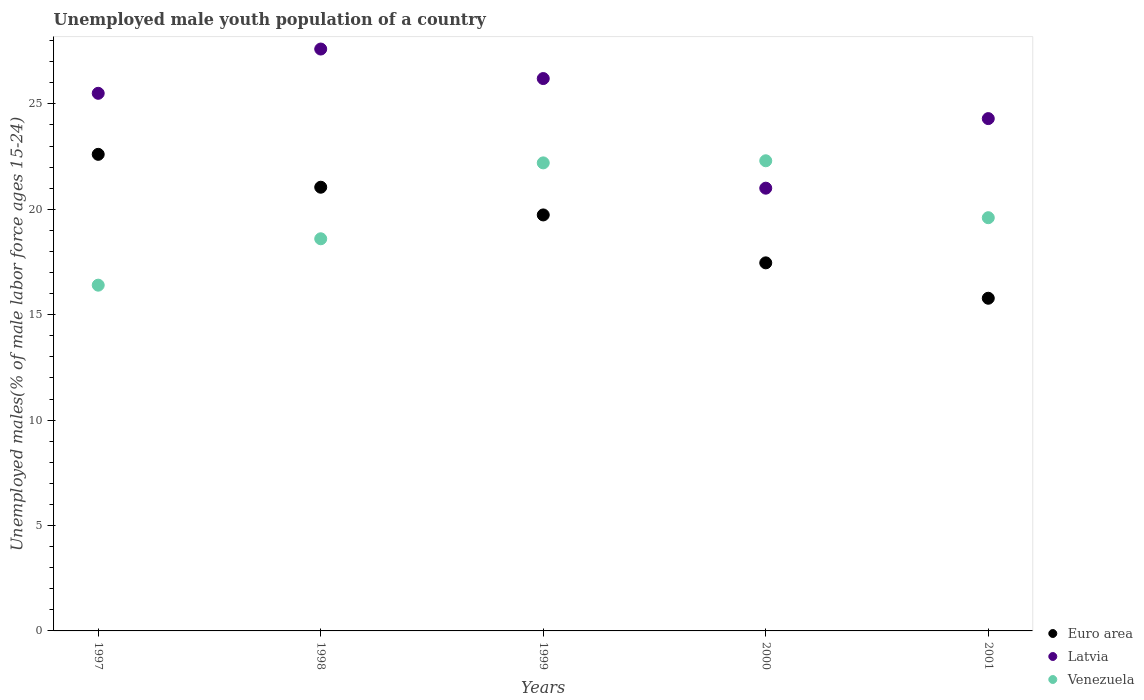What is the percentage of unemployed male youth population in Euro area in 2001?
Offer a terse response. 15.78. Across all years, what is the maximum percentage of unemployed male youth population in Venezuela?
Ensure brevity in your answer.  22.3. Across all years, what is the minimum percentage of unemployed male youth population in Venezuela?
Keep it short and to the point. 16.4. In which year was the percentage of unemployed male youth population in Latvia maximum?
Provide a short and direct response. 1998. In which year was the percentage of unemployed male youth population in Venezuela minimum?
Provide a short and direct response. 1997. What is the total percentage of unemployed male youth population in Euro area in the graph?
Provide a short and direct response. 96.62. What is the difference between the percentage of unemployed male youth population in Venezuela in 1999 and that in 2001?
Give a very brief answer. 2.6. What is the difference between the percentage of unemployed male youth population in Euro area in 1998 and the percentage of unemployed male youth population in Venezuela in 2001?
Offer a terse response. 1.45. What is the average percentage of unemployed male youth population in Venezuela per year?
Keep it short and to the point. 19.82. In the year 1998, what is the difference between the percentage of unemployed male youth population in Venezuela and percentage of unemployed male youth population in Euro area?
Keep it short and to the point. -2.45. In how many years, is the percentage of unemployed male youth population in Venezuela greater than 5 %?
Ensure brevity in your answer.  5. What is the ratio of the percentage of unemployed male youth population in Euro area in 1998 to that in 2000?
Your answer should be compact. 1.21. Is the percentage of unemployed male youth population in Latvia in 2000 less than that in 2001?
Offer a very short reply. Yes. Is the difference between the percentage of unemployed male youth population in Venezuela in 1998 and 2001 greater than the difference between the percentage of unemployed male youth population in Euro area in 1998 and 2001?
Keep it short and to the point. No. What is the difference between the highest and the second highest percentage of unemployed male youth population in Euro area?
Provide a succinct answer. 1.56. What is the difference between the highest and the lowest percentage of unemployed male youth population in Euro area?
Make the answer very short. 6.83. In how many years, is the percentage of unemployed male youth population in Euro area greater than the average percentage of unemployed male youth population in Euro area taken over all years?
Offer a terse response. 3. Is the percentage of unemployed male youth population in Venezuela strictly greater than the percentage of unemployed male youth population in Euro area over the years?
Provide a succinct answer. No. How many years are there in the graph?
Keep it short and to the point. 5. What is the difference between two consecutive major ticks on the Y-axis?
Your answer should be very brief. 5. Does the graph contain any zero values?
Your answer should be compact. No. What is the title of the graph?
Your answer should be compact. Unemployed male youth population of a country. Does "Middle income" appear as one of the legend labels in the graph?
Offer a terse response. No. What is the label or title of the X-axis?
Offer a terse response. Years. What is the label or title of the Y-axis?
Ensure brevity in your answer.  Unemployed males(% of male labor force ages 15-24). What is the Unemployed males(% of male labor force ages 15-24) in Euro area in 1997?
Give a very brief answer. 22.61. What is the Unemployed males(% of male labor force ages 15-24) in Venezuela in 1997?
Offer a very short reply. 16.4. What is the Unemployed males(% of male labor force ages 15-24) of Euro area in 1998?
Provide a short and direct response. 21.05. What is the Unemployed males(% of male labor force ages 15-24) in Latvia in 1998?
Keep it short and to the point. 27.6. What is the Unemployed males(% of male labor force ages 15-24) of Venezuela in 1998?
Keep it short and to the point. 18.6. What is the Unemployed males(% of male labor force ages 15-24) in Euro area in 1999?
Make the answer very short. 19.73. What is the Unemployed males(% of male labor force ages 15-24) of Latvia in 1999?
Make the answer very short. 26.2. What is the Unemployed males(% of male labor force ages 15-24) in Venezuela in 1999?
Offer a terse response. 22.2. What is the Unemployed males(% of male labor force ages 15-24) of Euro area in 2000?
Your response must be concise. 17.46. What is the Unemployed males(% of male labor force ages 15-24) of Latvia in 2000?
Offer a terse response. 21. What is the Unemployed males(% of male labor force ages 15-24) in Venezuela in 2000?
Offer a very short reply. 22.3. What is the Unemployed males(% of male labor force ages 15-24) of Euro area in 2001?
Your answer should be compact. 15.78. What is the Unemployed males(% of male labor force ages 15-24) of Latvia in 2001?
Ensure brevity in your answer.  24.3. What is the Unemployed males(% of male labor force ages 15-24) in Venezuela in 2001?
Make the answer very short. 19.6. Across all years, what is the maximum Unemployed males(% of male labor force ages 15-24) of Euro area?
Offer a terse response. 22.61. Across all years, what is the maximum Unemployed males(% of male labor force ages 15-24) of Latvia?
Provide a succinct answer. 27.6. Across all years, what is the maximum Unemployed males(% of male labor force ages 15-24) of Venezuela?
Give a very brief answer. 22.3. Across all years, what is the minimum Unemployed males(% of male labor force ages 15-24) of Euro area?
Provide a short and direct response. 15.78. Across all years, what is the minimum Unemployed males(% of male labor force ages 15-24) in Latvia?
Your response must be concise. 21. Across all years, what is the minimum Unemployed males(% of male labor force ages 15-24) of Venezuela?
Provide a short and direct response. 16.4. What is the total Unemployed males(% of male labor force ages 15-24) of Euro area in the graph?
Your answer should be compact. 96.62. What is the total Unemployed males(% of male labor force ages 15-24) in Latvia in the graph?
Provide a short and direct response. 124.6. What is the total Unemployed males(% of male labor force ages 15-24) in Venezuela in the graph?
Ensure brevity in your answer.  99.1. What is the difference between the Unemployed males(% of male labor force ages 15-24) of Euro area in 1997 and that in 1998?
Provide a succinct answer. 1.56. What is the difference between the Unemployed males(% of male labor force ages 15-24) of Euro area in 1997 and that in 1999?
Give a very brief answer. 2.87. What is the difference between the Unemployed males(% of male labor force ages 15-24) in Venezuela in 1997 and that in 1999?
Ensure brevity in your answer.  -5.8. What is the difference between the Unemployed males(% of male labor force ages 15-24) of Euro area in 1997 and that in 2000?
Provide a succinct answer. 5.15. What is the difference between the Unemployed males(% of male labor force ages 15-24) of Euro area in 1997 and that in 2001?
Give a very brief answer. 6.83. What is the difference between the Unemployed males(% of male labor force ages 15-24) in Euro area in 1998 and that in 1999?
Keep it short and to the point. 1.31. What is the difference between the Unemployed males(% of male labor force ages 15-24) of Euro area in 1998 and that in 2000?
Provide a succinct answer. 3.59. What is the difference between the Unemployed males(% of male labor force ages 15-24) in Latvia in 1998 and that in 2000?
Your answer should be compact. 6.6. What is the difference between the Unemployed males(% of male labor force ages 15-24) of Venezuela in 1998 and that in 2000?
Offer a very short reply. -3.7. What is the difference between the Unemployed males(% of male labor force ages 15-24) in Euro area in 1998 and that in 2001?
Ensure brevity in your answer.  5.27. What is the difference between the Unemployed males(% of male labor force ages 15-24) of Venezuela in 1998 and that in 2001?
Offer a terse response. -1. What is the difference between the Unemployed males(% of male labor force ages 15-24) of Euro area in 1999 and that in 2000?
Give a very brief answer. 2.27. What is the difference between the Unemployed males(% of male labor force ages 15-24) in Latvia in 1999 and that in 2000?
Your response must be concise. 5.2. What is the difference between the Unemployed males(% of male labor force ages 15-24) of Euro area in 1999 and that in 2001?
Provide a short and direct response. 3.95. What is the difference between the Unemployed males(% of male labor force ages 15-24) of Euro area in 2000 and that in 2001?
Offer a terse response. 1.68. What is the difference between the Unemployed males(% of male labor force ages 15-24) in Latvia in 2000 and that in 2001?
Offer a very short reply. -3.3. What is the difference between the Unemployed males(% of male labor force ages 15-24) of Venezuela in 2000 and that in 2001?
Provide a short and direct response. 2.7. What is the difference between the Unemployed males(% of male labor force ages 15-24) in Euro area in 1997 and the Unemployed males(% of male labor force ages 15-24) in Latvia in 1998?
Keep it short and to the point. -4.99. What is the difference between the Unemployed males(% of male labor force ages 15-24) in Euro area in 1997 and the Unemployed males(% of male labor force ages 15-24) in Venezuela in 1998?
Offer a very short reply. 4.01. What is the difference between the Unemployed males(% of male labor force ages 15-24) of Latvia in 1997 and the Unemployed males(% of male labor force ages 15-24) of Venezuela in 1998?
Your answer should be compact. 6.9. What is the difference between the Unemployed males(% of male labor force ages 15-24) of Euro area in 1997 and the Unemployed males(% of male labor force ages 15-24) of Latvia in 1999?
Keep it short and to the point. -3.59. What is the difference between the Unemployed males(% of male labor force ages 15-24) of Euro area in 1997 and the Unemployed males(% of male labor force ages 15-24) of Venezuela in 1999?
Keep it short and to the point. 0.41. What is the difference between the Unemployed males(% of male labor force ages 15-24) of Latvia in 1997 and the Unemployed males(% of male labor force ages 15-24) of Venezuela in 1999?
Provide a succinct answer. 3.3. What is the difference between the Unemployed males(% of male labor force ages 15-24) in Euro area in 1997 and the Unemployed males(% of male labor force ages 15-24) in Latvia in 2000?
Provide a succinct answer. 1.61. What is the difference between the Unemployed males(% of male labor force ages 15-24) in Euro area in 1997 and the Unemployed males(% of male labor force ages 15-24) in Venezuela in 2000?
Your answer should be compact. 0.31. What is the difference between the Unemployed males(% of male labor force ages 15-24) in Latvia in 1997 and the Unemployed males(% of male labor force ages 15-24) in Venezuela in 2000?
Provide a succinct answer. 3.2. What is the difference between the Unemployed males(% of male labor force ages 15-24) of Euro area in 1997 and the Unemployed males(% of male labor force ages 15-24) of Latvia in 2001?
Provide a succinct answer. -1.69. What is the difference between the Unemployed males(% of male labor force ages 15-24) of Euro area in 1997 and the Unemployed males(% of male labor force ages 15-24) of Venezuela in 2001?
Provide a succinct answer. 3.01. What is the difference between the Unemployed males(% of male labor force ages 15-24) of Latvia in 1997 and the Unemployed males(% of male labor force ages 15-24) of Venezuela in 2001?
Your answer should be very brief. 5.9. What is the difference between the Unemployed males(% of male labor force ages 15-24) in Euro area in 1998 and the Unemployed males(% of male labor force ages 15-24) in Latvia in 1999?
Keep it short and to the point. -5.15. What is the difference between the Unemployed males(% of male labor force ages 15-24) of Euro area in 1998 and the Unemployed males(% of male labor force ages 15-24) of Venezuela in 1999?
Your response must be concise. -1.15. What is the difference between the Unemployed males(% of male labor force ages 15-24) of Euro area in 1998 and the Unemployed males(% of male labor force ages 15-24) of Latvia in 2000?
Provide a short and direct response. 0.05. What is the difference between the Unemployed males(% of male labor force ages 15-24) in Euro area in 1998 and the Unemployed males(% of male labor force ages 15-24) in Venezuela in 2000?
Offer a terse response. -1.25. What is the difference between the Unemployed males(% of male labor force ages 15-24) of Euro area in 1998 and the Unemployed males(% of male labor force ages 15-24) of Latvia in 2001?
Offer a terse response. -3.25. What is the difference between the Unemployed males(% of male labor force ages 15-24) in Euro area in 1998 and the Unemployed males(% of male labor force ages 15-24) in Venezuela in 2001?
Your answer should be compact. 1.45. What is the difference between the Unemployed males(% of male labor force ages 15-24) of Latvia in 1998 and the Unemployed males(% of male labor force ages 15-24) of Venezuela in 2001?
Your response must be concise. 8. What is the difference between the Unemployed males(% of male labor force ages 15-24) of Euro area in 1999 and the Unemployed males(% of male labor force ages 15-24) of Latvia in 2000?
Keep it short and to the point. -1.27. What is the difference between the Unemployed males(% of male labor force ages 15-24) of Euro area in 1999 and the Unemployed males(% of male labor force ages 15-24) of Venezuela in 2000?
Make the answer very short. -2.57. What is the difference between the Unemployed males(% of male labor force ages 15-24) in Euro area in 1999 and the Unemployed males(% of male labor force ages 15-24) in Latvia in 2001?
Provide a short and direct response. -4.57. What is the difference between the Unemployed males(% of male labor force ages 15-24) in Euro area in 1999 and the Unemployed males(% of male labor force ages 15-24) in Venezuela in 2001?
Provide a short and direct response. 0.13. What is the difference between the Unemployed males(% of male labor force ages 15-24) of Latvia in 1999 and the Unemployed males(% of male labor force ages 15-24) of Venezuela in 2001?
Ensure brevity in your answer.  6.6. What is the difference between the Unemployed males(% of male labor force ages 15-24) in Euro area in 2000 and the Unemployed males(% of male labor force ages 15-24) in Latvia in 2001?
Your answer should be very brief. -6.84. What is the difference between the Unemployed males(% of male labor force ages 15-24) in Euro area in 2000 and the Unemployed males(% of male labor force ages 15-24) in Venezuela in 2001?
Give a very brief answer. -2.14. What is the difference between the Unemployed males(% of male labor force ages 15-24) in Latvia in 2000 and the Unemployed males(% of male labor force ages 15-24) in Venezuela in 2001?
Offer a very short reply. 1.4. What is the average Unemployed males(% of male labor force ages 15-24) in Euro area per year?
Offer a very short reply. 19.32. What is the average Unemployed males(% of male labor force ages 15-24) of Latvia per year?
Give a very brief answer. 24.92. What is the average Unemployed males(% of male labor force ages 15-24) of Venezuela per year?
Give a very brief answer. 19.82. In the year 1997, what is the difference between the Unemployed males(% of male labor force ages 15-24) in Euro area and Unemployed males(% of male labor force ages 15-24) in Latvia?
Your response must be concise. -2.89. In the year 1997, what is the difference between the Unemployed males(% of male labor force ages 15-24) in Euro area and Unemployed males(% of male labor force ages 15-24) in Venezuela?
Your response must be concise. 6.21. In the year 1997, what is the difference between the Unemployed males(% of male labor force ages 15-24) of Latvia and Unemployed males(% of male labor force ages 15-24) of Venezuela?
Your answer should be compact. 9.1. In the year 1998, what is the difference between the Unemployed males(% of male labor force ages 15-24) in Euro area and Unemployed males(% of male labor force ages 15-24) in Latvia?
Offer a terse response. -6.55. In the year 1998, what is the difference between the Unemployed males(% of male labor force ages 15-24) of Euro area and Unemployed males(% of male labor force ages 15-24) of Venezuela?
Provide a short and direct response. 2.45. In the year 1999, what is the difference between the Unemployed males(% of male labor force ages 15-24) in Euro area and Unemployed males(% of male labor force ages 15-24) in Latvia?
Make the answer very short. -6.47. In the year 1999, what is the difference between the Unemployed males(% of male labor force ages 15-24) of Euro area and Unemployed males(% of male labor force ages 15-24) of Venezuela?
Keep it short and to the point. -2.47. In the year 1999, what is the difference between the Unemployed males(% of male labor force ages 15-24) of Latvia and Unemployed males(% of male labor force ages 15-24) of Venezuela?
Give a very brief answer. 4. In the year 2000, what is the difference between the Unemployed males(% of male labor force ages 15-24) in Euro area and Unemployed males(% of male labor force ages 15-24) in Latvia?
Your response must be concise. -3.54. In the year 2000, what is the difference between the Unemployed males(% of male labor force ages 15-24) of Euro area and Unemployed males(% of male labor force ages 15-24) of Venezuela?
Provide a succinct answer. -4.84. In the year 2001, what is the difference between the Unemployed males(% of male labor force ages 15-24) of Euro area and Unemployed males(% of male labor force ages 15-24) of Latvia?
Provide a short and direct response. -8.52. In the year 2001, what is the difference between the Unemployed males(% of male labor force ages 15-24) of Euro area and Unemployed males(% of male labor force ages 15-24) of Venezuela?
Provide a short and direct response. -3.82. What is the ratio of the Unemployed males(% of male labor force ages 15-24) in Euro area in 1997 to that in 1998?
Give a very brief answer. 1.07. What is the ratio of the Unemployed males(% of male labor force ages 15-24) in Latvia in 1997 to that in 1998?
Provide a short and direct response. 0.92. What is the ratio of the Unemployed males(% of male labor force ages 15-24) in Venezuela in 1997 to that in 1998?
Offer a very short reply. 0.88. What is the ratio of the Unemployed males(% of male labor force ages 15-24) of Euro area in 1997 to that in 1999?
Offer a terse response. 1.15. What is the ratio of the Unemployed males(% of male labor force ages 15-24) of Latvia in 1997 to that in 1999?
Offer a very short reply. 0.97. What is the ratio of the Unemployed males(% of male labor force ages 15-24) in Venezuela in 1997 to that in 1999?
Your answer should be compact. 0.74. What is the ratio of the Unemployed males(% of male labor force ages 15-24) in Euro area in 1997 to that in 2000?
Ensure brevity in your answer.  1.29. What is the ratio of the Unemployed males(% of male labor force ages 15-24) in Latvia in 1997 to that in 2000?
Your response must be concise. 1.21. What is the ratio of the Unemployed males(% of male labor force ages 15-24) of Venezuela in 1997 to that in 2000?
Offer a terse response. 0.74. What is the ratio of the Unemployed males(% of male labor force ages 15-24) in Euro area in 1997 to that in 2001?
Offer a very short reply. 1.43. What is the ratio of the Unemployed males(% of male labor force ages 15-24) in Latvia in 1997 to that in 2001?
Offer a very short reply. 1.05. What is the ratio of the Unemployed males(% of male labor force ages 15-24) in Venezuela in 1997 to that in 2001?
Keep it short and to the point. 0.84. What is the ratio of the Unemployed males(% of male labor force ages 15-24) of Euro area in 1998 to that in 1999?
Give a very brief answer. 1.07. What is the ratio of the Unemployed males(% of male labor force ages 15-24) of Latvia in 1998 to that in 1999?
Provide a succinct answer. 1.05. What is the ratio of the Unemployed males(% of male labor force ages 15-24) of Venezuela in 1998 to that in 1999?
Make the answer very short. 0.84. What is the ratio of the Unemployed males(% of male labor force ages 15-24) in Euro area in 1998 to that in 2000?
Keep it short and to the point. 1.21. What is the ratio of the Unemployed males(% of male labor force ages 15-24) in Latvia in 1998 to that in 2000?
Offer a terse response. 1.31. What is the ratio of the Unemployed males(% of male labor force ages 15-24) in Venezuela in 1998 to that in 2000?
Your response must be concise. 0.83. What is the ratio of the Unemployed males(% of male labor force ages 15-24) of Euro area in 1998 to that in 2001?
Give a very brief answer. 1.33. What is the ratio of the Unemployed males(% of male labor force ages 15-24) of Latvia in 1998 to that in 2001?
Provide a short and direct response. 1.14. What is the ratio of the Unemployed males(% of male labor force ages 15-24) of Venezuela in 1998 to that in 2001?
Provide a short and direct response. 0.95. What is the ratio of the Unemployed males(% of male labor force ages 15-24) in Euro area in 1999 to that in 2000?
Make the answer very short. 1.13. What is the ratio of the Unemployed males(% of male labor force ages 15-24) in Latvia in 1999 to that in 2000?
Offer a terse response. 1.25. What is the ratio of the Unemployed males(% of male labor force ages 15-24) of Venezuela in 1999 to that in 2000?
Your answer should be compact. 1. What is the ratio of the Unemployed males(% of male labor force ages 15-24) of Euro area in 1999 to that in 2001?
Give a very brief answer. 1.25. What is the ratio of the Unemployed males(% of male labor force ages 15-24) of Latvia in 1999 to that in 2001?
Offer a very short reply. 1.08. What is the ratio of the Unemployed males(% of male labor force ages 15-24) of Venezuela in 1999 to that in 2001?
Provide a short and direct response. 1.13. What is the ratio of the Unemployed males(% of male labor force ages 15-24) in Euro area in 2000 to that in 2001?
Make the answer very short. 1.11. What is the ratio of the Unemployed males(% of male labor force ages 15-24) in Latvia in 2000 to that in 2001?
Provide a succinct answer. 0.86. What is the ratio of the Unemployed males(% of male labor force ages 15-24) in Venezuela in 2000 to that in 2001?
Make the answer very short. 1.14. What is the difference between the highest and the second highest Unemployed males(% of male labor force ages 15-24) of Euro area?
Your answer should be very brief. 1.56. What is the difference between the highest and the second highest Unemployed males(% of male labor force ages 15-24) in Venezuela?
Offer a terse response. 0.1. What is the difference between the highest and the lowest Unemployed males(% of male labor force ages 15-24) in Euro area?
Your response must be concise. 6.83. What is the difference between the highest and the lowest Unemployed males(% of male labor force ages 15-24) in Venezuela?
Make the answer very short. 5.9. 